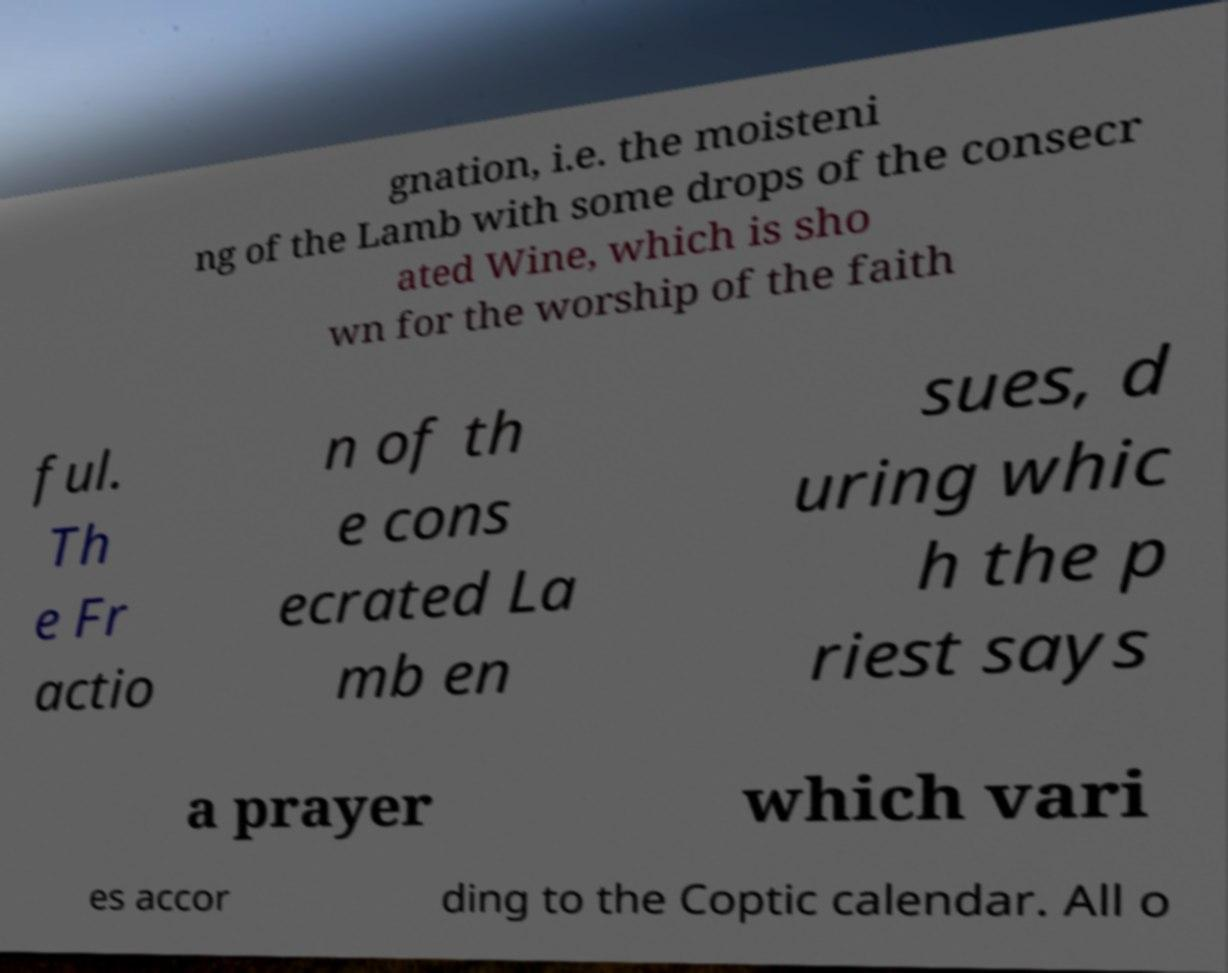I need the written content from this picture converted into text. Can you do that? gnation, i.e. the moisteni ng of the Lamb with some drops of the consecr ated Wine, which is sho wn for the worship of the faith ful. Th e Fr actio n of th e cons ecrated La mb en sues, d uring whic h the p riest says a prayer which vari es accor ding to the Coptic calendar. All o 